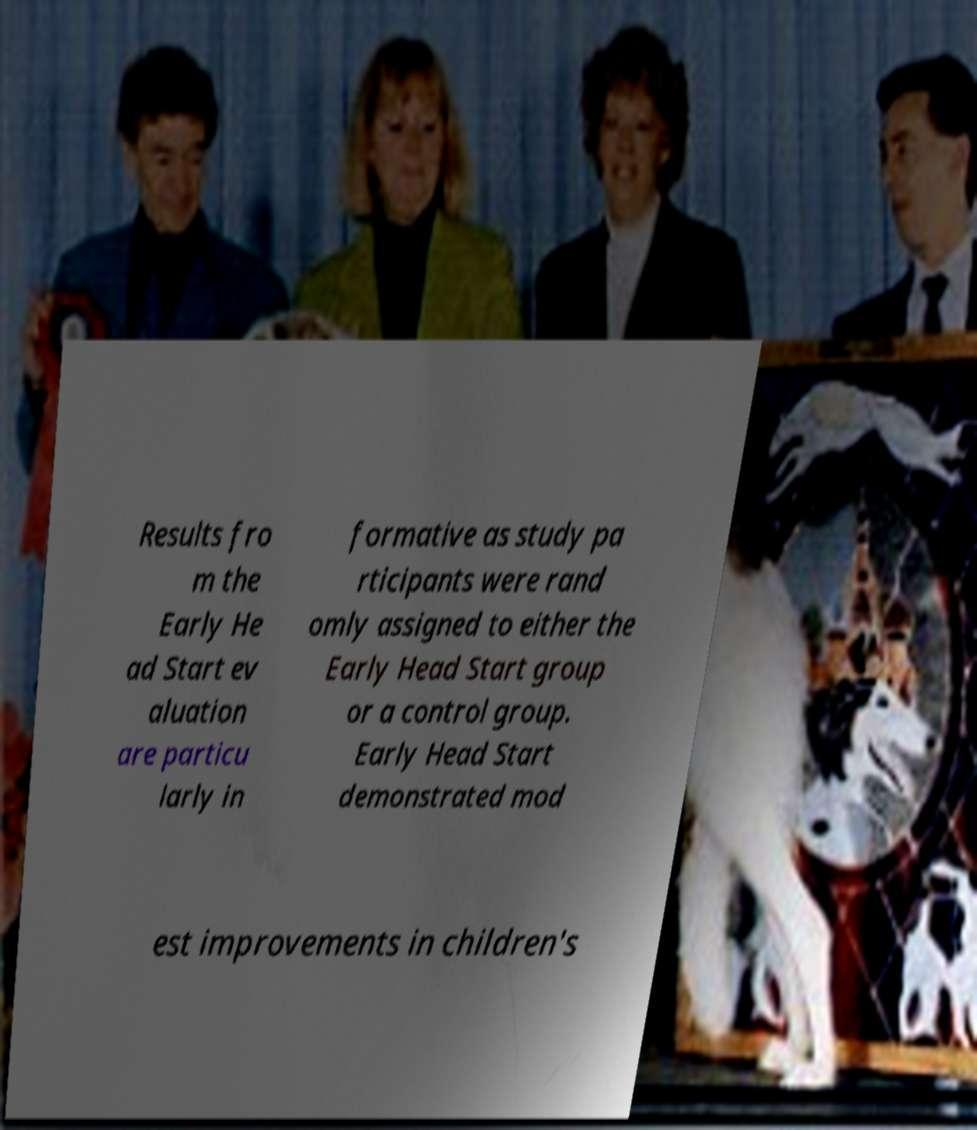What messages or text are displayed in this image? I need them in a readable, typed format. Results fro m the Early He ad Start ev aluation are particu larly in formative as study pa rticipants were rand omly assigned to either the Early Head Start group or a control group. Early Head Start demonstrated mod est improvements in children's 